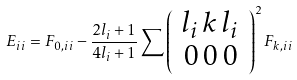<formula> <loc_0><loc_0><loc_500><loc_500>E _ { i i } = F _ { 0 , i i } - \frac { 2 l _ { i } + 1 } { 4 l _ { i } + 1 } \sum \left ( \begin{array} { c c c } l _ { i } \, k \, l _ { i } \\ 0 \, 0 \, 0 \end{array} \right ) ^ { 2 } F _ { k , i i }</formula> 